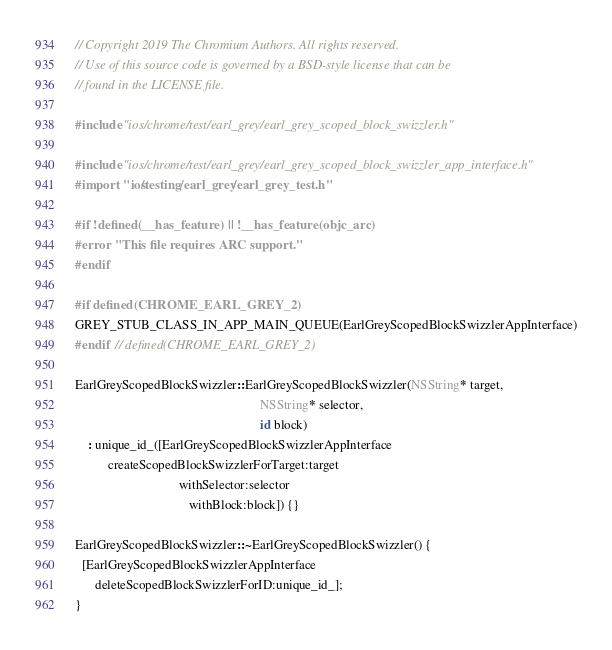Convert code to text. <code><loc_0><loc_0><loc_500><loc_500><_ObjectiveC_>// Copyright 2019 The Chromium Authors. All rights reserved.
// Use of this source code is governed by a BSD-style license that can be
// found in the LICENSE file.

#include "ios/chrome/test/earl_grey/earl_grey_scoped_block_swizzler.h"

#include "ios/chrome/test/earl_grey/earl_grey_scoped_block_swizzler_app_interface.h"
#import "ios/testing/earl_grey/earl_grey_test.h"

#if !defined(__has_feature) || !__has_feature(objc_arc)
#error "This file requires ARC support."
#endif

#if defined(CHROME_EARL_GREY_2)
GREY_STUB_CLASS_IN_APP_MAIN_QUEUE(EarlGreyScopedBlockSwizzlerAppInterface)
#endif  // defined(CHROME_EARL_GREY_2)

EarlGreyScopedBlockSwizzler::EarlGreyScopedBlockSwizzler(NSString* target,
                                                         NSString* selector,
                                                         id block)
    : unique_id_([EarlGreyScopedBlockSwizzlerAppInterface
          createScopedBlockSwizzlerForTarget:target
                                withSelector:selector
                                   withBlock:block]) {}

EarlGreyScopedBlockSwizzler::~EarlGreyScopedBlockSwizzler() {
  [EarlGreyScopedBlockSwizzlerAppInterface
      deleteScopedBlockSwizzlerForID:unique_id_];
}
</code> 